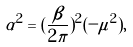<formula> <loc_0><loc_0><loc_500><loc_500>\alpha ^ { 2 } = ( \frac { \beta } { 2 \pi } ) ^ { 2 } ( - \mu ^ { 2 } ) ,</formula> 